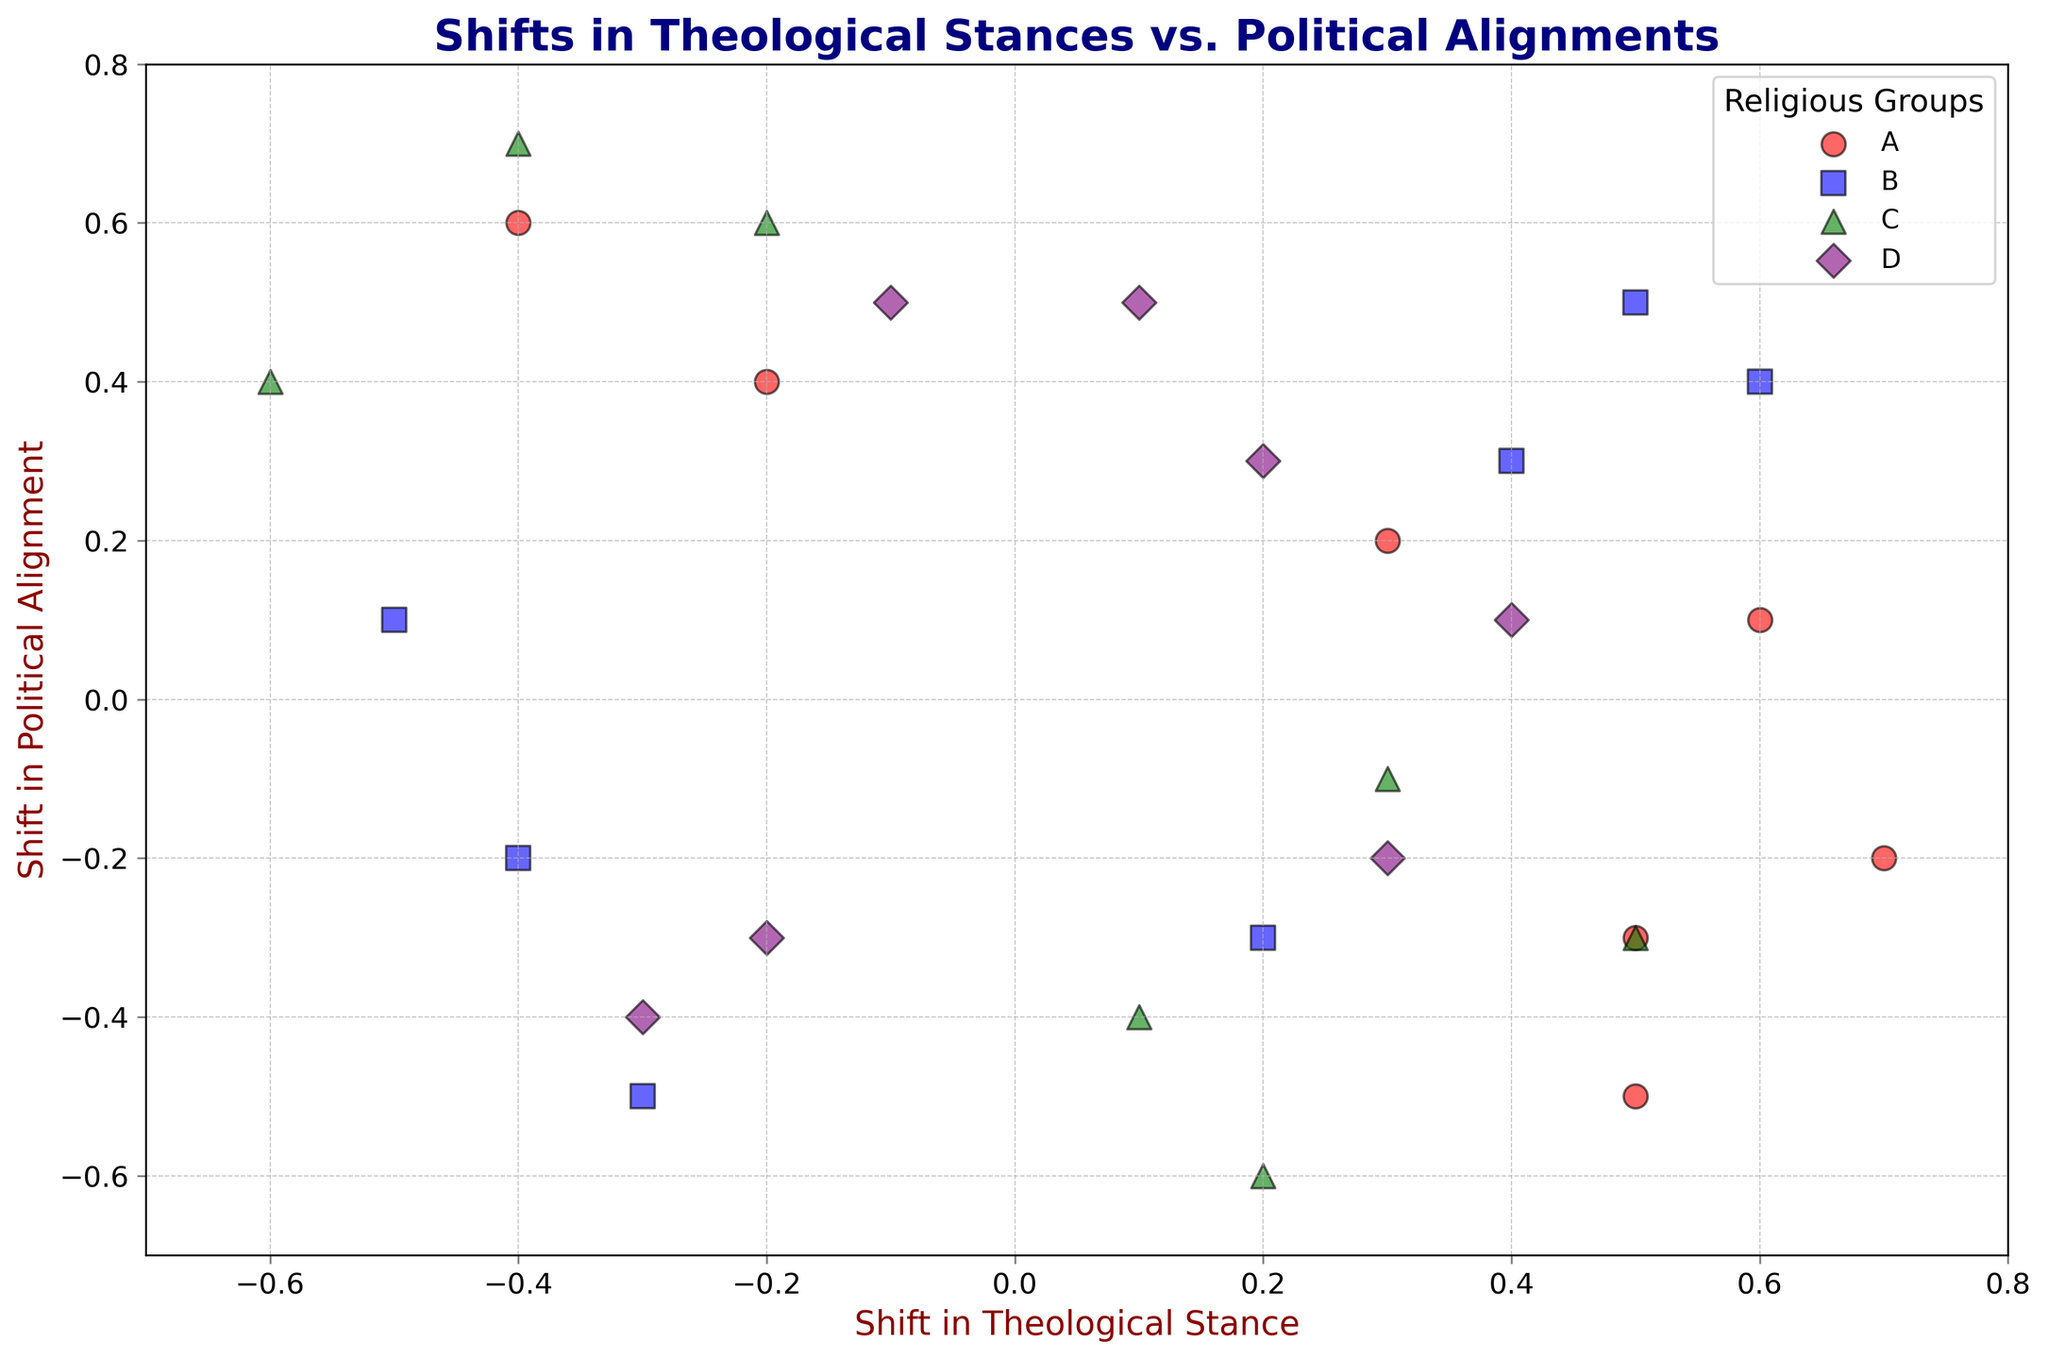What is the range of shifts in theological stance for Group A? The range is the difference between the maximum and minimum values. For Group A, the shifts in theological stance values are [0.5, 0.6, -0.2, 0.7, -0.4, 0.5, 0.3]. The maximum value is 0.7, and the minimum value is -0.4. Therefore, the range is 0.7 - (-0.4) = 1.1
Answer: 1.1 Which group shows the most positive shift in political alignment in any year? To determine this, we look at the highest value in the 'Shift in Political Alignment' dimension across all groups. The maximum value in the data is 0.7 associated with Group C in 2005.
Answer: Group C How many times does Group B show negative shifts in both theological stance and political alignment? By checking the values for Group B: In 1990 (-0.3, -0.5), 2000 (-0.5, 0.1), and 2015 (-0.4, -0.2), we see negative shifts in both categories in two instances.
Answer: 2 What is the average shift in political alignment for Group D over the years? To find the average shift in political alignment for Group D, sum all the respective values: (0.5, -0.2, 0.3, -0.4, 0.1, -0.3, 0.5) amounts to 0.5 + (-0.2) + 0.3 + (-0.4) + 0.1 + (-0.3) + 0.5 = 0.5. The average is then 0.5 / 7 ≈ 0.071.
Answer: 0.071 Between Group A and Group B, which has more instances where the shift in theological stance is greater than 0.5? Group A receives a visual check: 0.5 (yes), 0.6 (yes), -0.2 (no), 0.7 (yes), -0.4 (no), 0.5 (yes), 0.3 (no) resulting in 4 instances. Group B: -0.3 (no), 0.4 (no), -0.5 (no), 0.2 (no), 0.6 (yes), -0.4 (no), 0.5 (yes) resulting in 2 instances.
Answer: Group A 